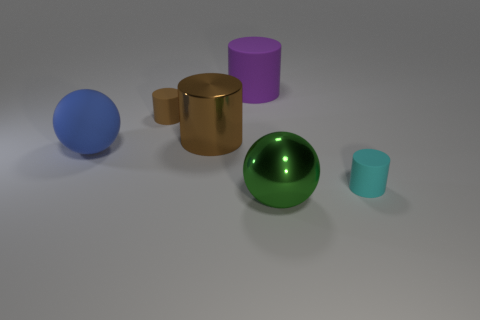Subtract all small cyan rubber cylinders. How many cylinders are left? 3 Add 1 tiny gray cylinders. How many objects exist? 7 Subtract all blue balls. How many balls are left? 1 Subtract all balls. How many objects are left? 4 Subtract 2 cylinders. How many cylinders are left? 2 Subtract all yellow cylinders. Subtract all cyan spheres. How many cylinders are left? 4 Subtract all gray cubes. How many blue spheres are left? 1 Subtract all purple matte cylinders. Subtract all green metal objects. How many objects are left? 4 Add 3 big brown shiny objects. How many big brown shiny objects are left? 4 Add 6 red metal spheres. How many red metal spheres exist? 6 